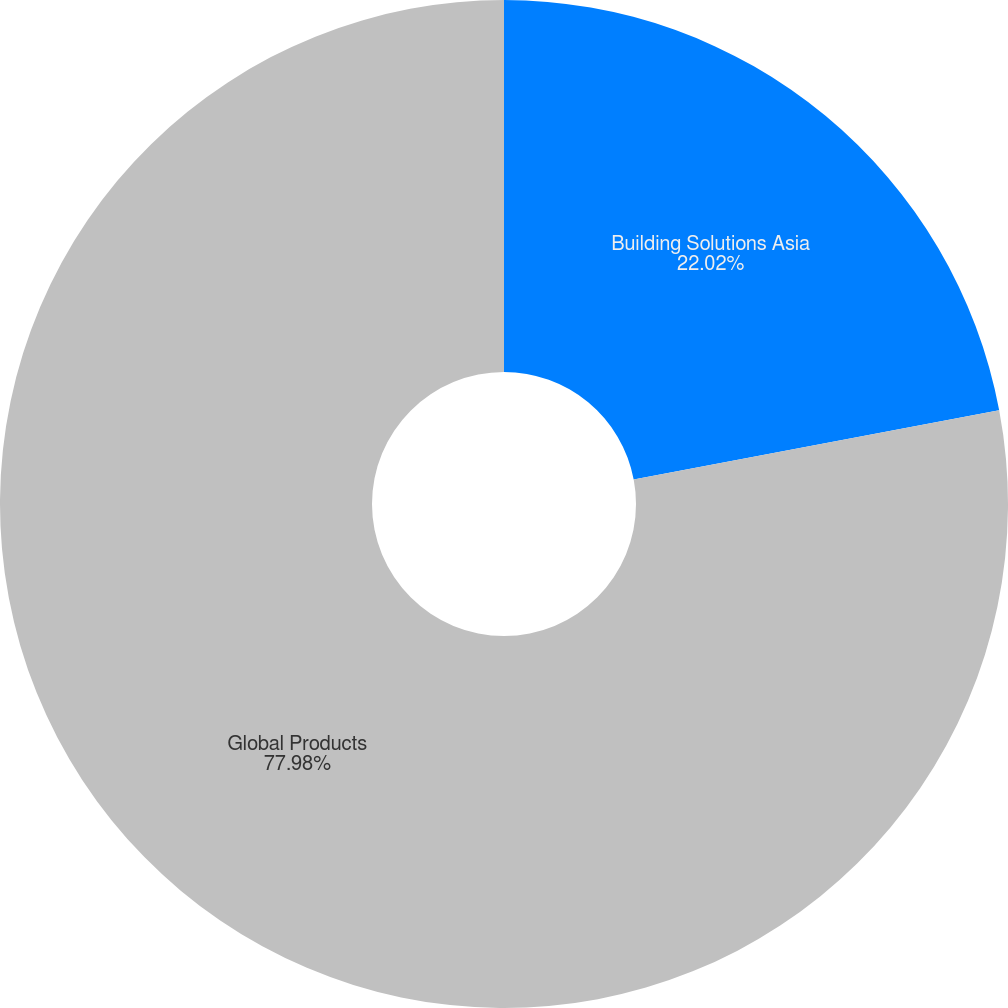<chart> <loc_0><loc_0><loc_500><loc_500><pie_chart><fcel>Building Solutions Asia<fcel>Global Products<nl><fcel>22.02%<fcel>77.98%<nl></chart> 